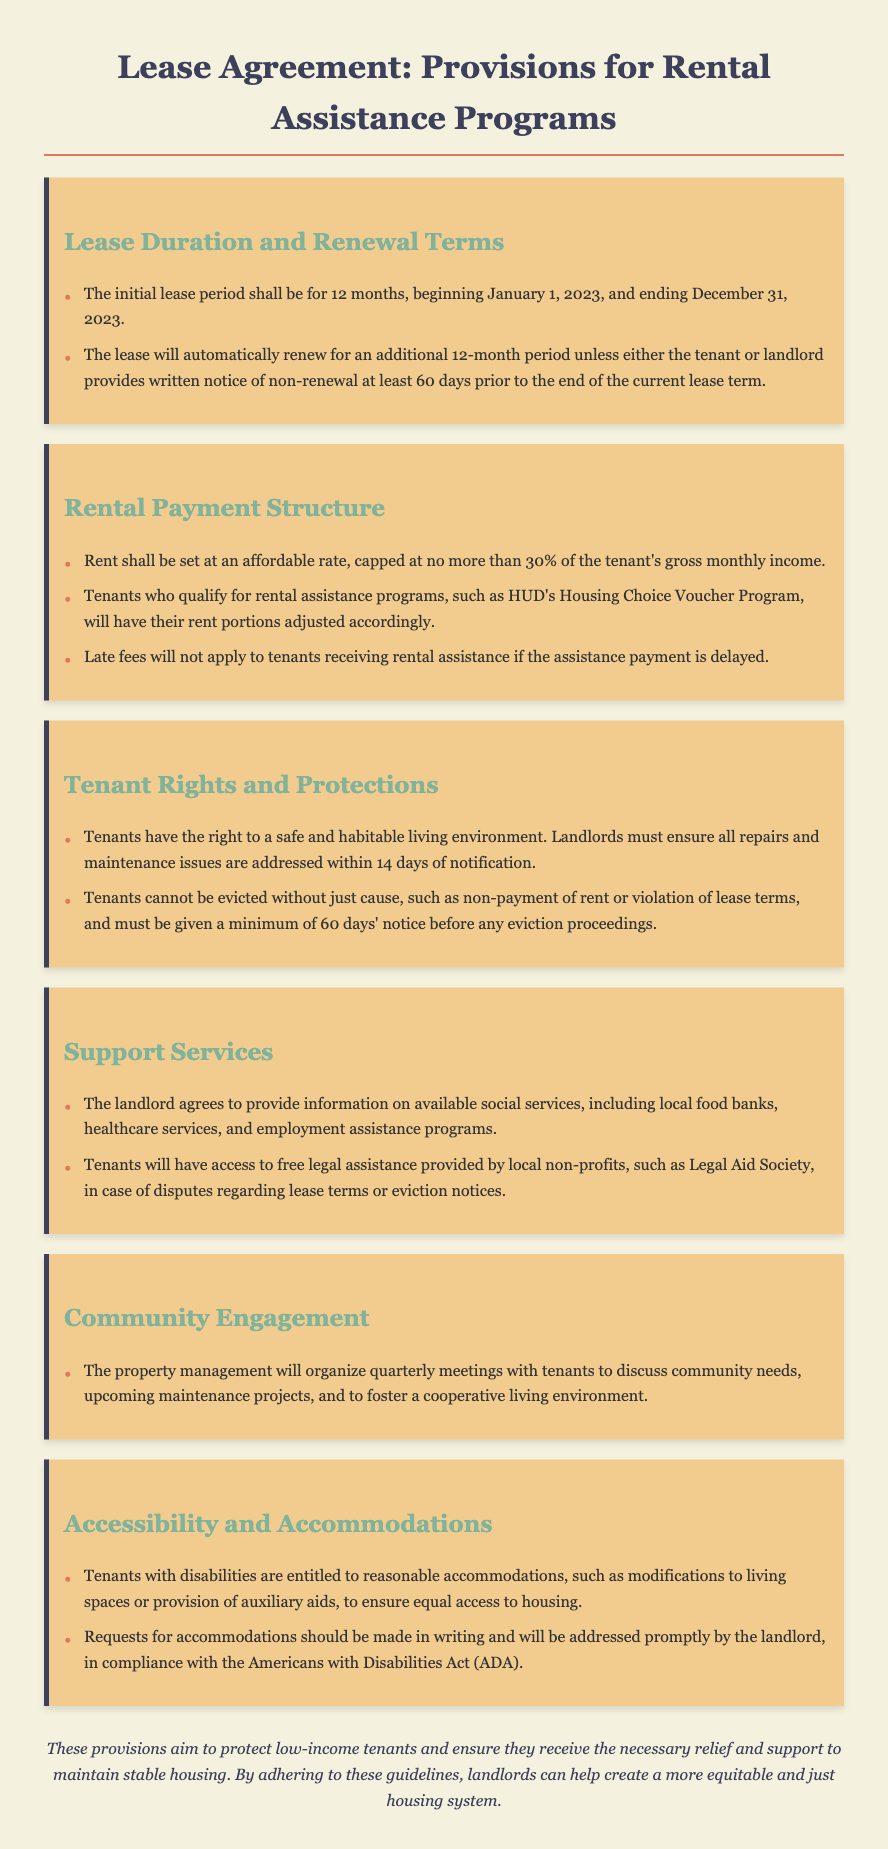What is the initial lease period? The initial lease period is specified in the document as the duration from January 1, 2023, to December 31, 2023.
Answer: 12 months What percentage of the tenant's gross monthly income is rent capped at? The rental payment structure states that rent is capped at no more than 30% of the tenant's gross monthly income.
Answer: 30% How many days' notice must be given for non-renewal of the lease? The renewal terms require either party to provide written notice of non-renewal at least 60 days prior to the end of the current lease term.
Answer: 60 days What support service is provided for tenants in case of disputes? The lease agreement mentions free legal assistance provided by local non-profits, such as the Legal Aid Society.
Answer: Free legal assistance What right do tenants have in terms of eviction notice? The document states that tenants must be given a minimum of 60 days’ notice before any eviction proceedings.
Answer: 60 days What must landlords ensure regarding the living environment? The tenant rights and protections section requires landlords to provide a safe and habitable living environment.
Answer: Safe and habitable What accommodations are tenants with disabilities entitled to? The lease specifies that tenants with disabilities are entitled to reasonable accommodations to ensure equal access to housing.
Answer: Reasonable accommodations How often will community meetings be organized? The community engagement section of the lease states that the property management will organize quarterly meetings with tenants.
Answer: Quarterly What is the acknowledgment of the landlord regarding social services? The landlord agrees to provide information on available social services, including local food banks, healthcare services, and employment assistance programs.
Answer: Information on social services 